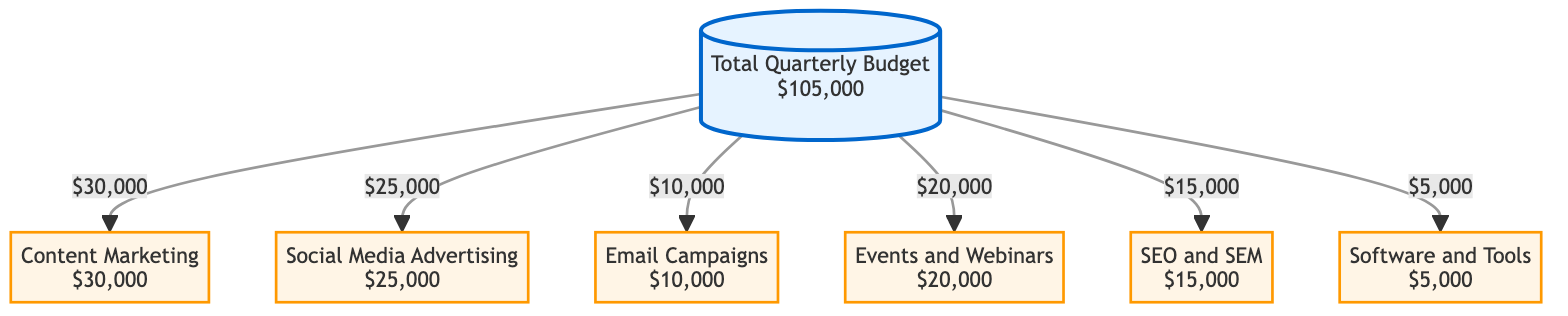What's the total quarterly budget allocated for marketing activities? The diagram clearly states "Total Quarterly Budget" with the value "$105,000", which represents the entire budget available for marketing activities in this quarter.
Answer: $105,000 How much is allocated for Content Marketing? In the diagram, the node for "Content Marketing" specifies an allocation of "$30,000". This represents the specific budget assigned to this category of marketing activity.
Answer: $30,000 What is the smallest budget category listed in the diagram? By examining the amounts for each category, "$5,000" for "Software and Tools" is the lowest value, making it the smallest budget category.
Answer: Software and Tools How many categories are included in the budget allocation? The diagram provides a list of 6 distinct budget categories: Content Marketing, Social Media Advertising, Email Campaigns, Events and Webinars, SEO and SEM, and Software and Tools. This means there are a total of 6 categories.
Answer: 6 Which category has the highest budget allocation? The diagram shows the amounts allocated for each category, with "Content Marketing" at "$30,000", which is the highest among all categories listed in the diagram.
Answer: Content Marketing How much more is allocated for Social Media Advertising compared to Email Campaigns? The allocation for Social Media Advertising is "$25,000", and for Email Campaigns, it is "$10,000". The difference is calculated as $25,000 - $10,000 = $15,000.
Answer: $15,000 How many of the allocation categories exceed $20,000? The categories earning more than $20,000 are "Content Marketing" ($30,000) and "Events and Webinars" ($20,000), giving a total of 2 such categories.
Answer: 2 What is the sum of the budgets for SEO and SEM and Software and Tools? Summing the amounts for these two categories: "$15,000" for SEO and SEM and "$5,000" for Software and Tools leads to $15,000 + $5,000 = $20,000.
Answer: $20,000 Is the budget for Email Campaigns more than half of the total budget? Half of the total budget ($105,000) is $52,500. The budget for Email Campaigns is "$10,000", which is significantly less than $52,500.
Answer: No 